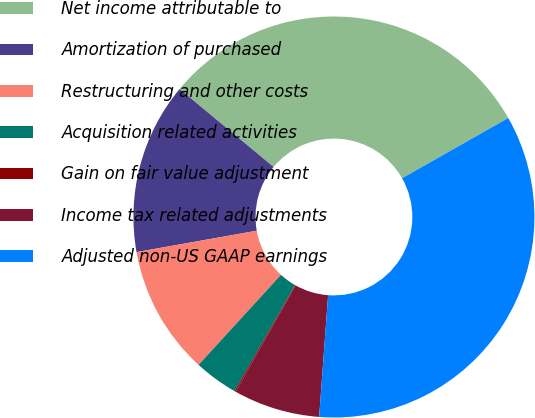<chart> <loc_0><loc_0><loc_500><loc_500><pie_chart><fcel>Net income attributable to<fcel>Amortization of purchased<fcel>Restructuring and other costs<fcel>Acquisition related activities<fcel>Gain on fair value adjustment<fcel>Income tax related adjustments<fcel>Adjusted non-US GAAP earnings<nl><fcel>30.76%<fcel>13.82%<fcel>10.4%<fcel>3.54%<fcel>0.11%<fcel>6.97%<fcel>34.39%<nl></chart> 